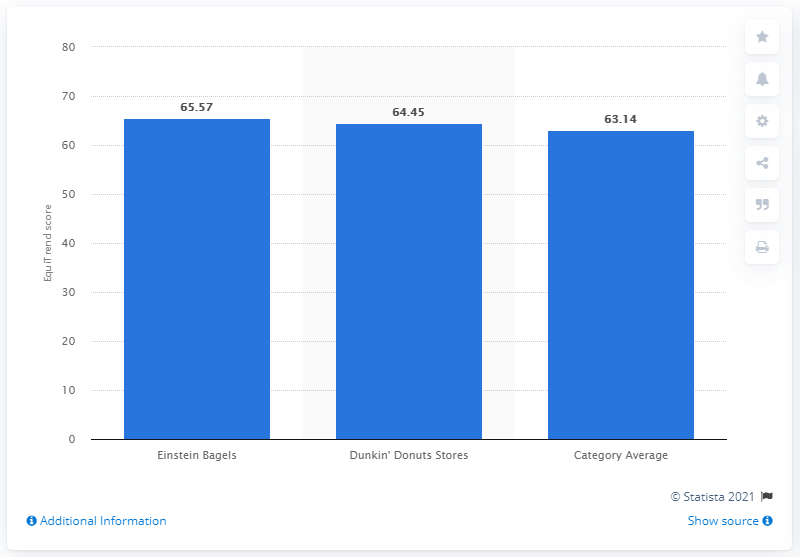Mention a couple of crucial points in this snapshot. Einstein Bagels has an EquiTrend score of 65.57, making it a popular choice among diners. In 2012, Einstein Bagels earned a EquiTrend score of 65.57, indicating high customer satisfaction and brand recognition. 